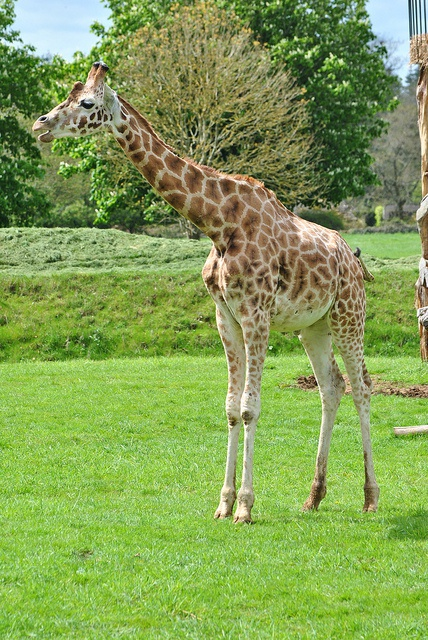Describe the objects in this image and their specific colors. I can see a giraffe in lightblue, olive, darkgray, and gray tones in this image. 